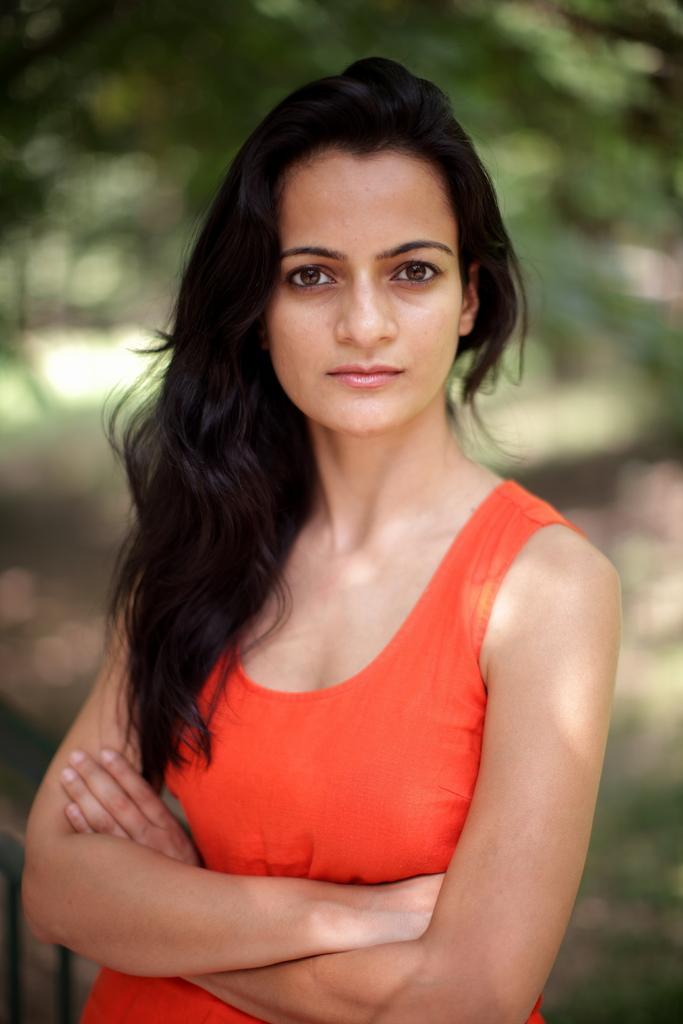How would you summarize this image in a sentence or two? In this picture we can see a woman in the orange tank top. Behind the woman there is the blurred background. 